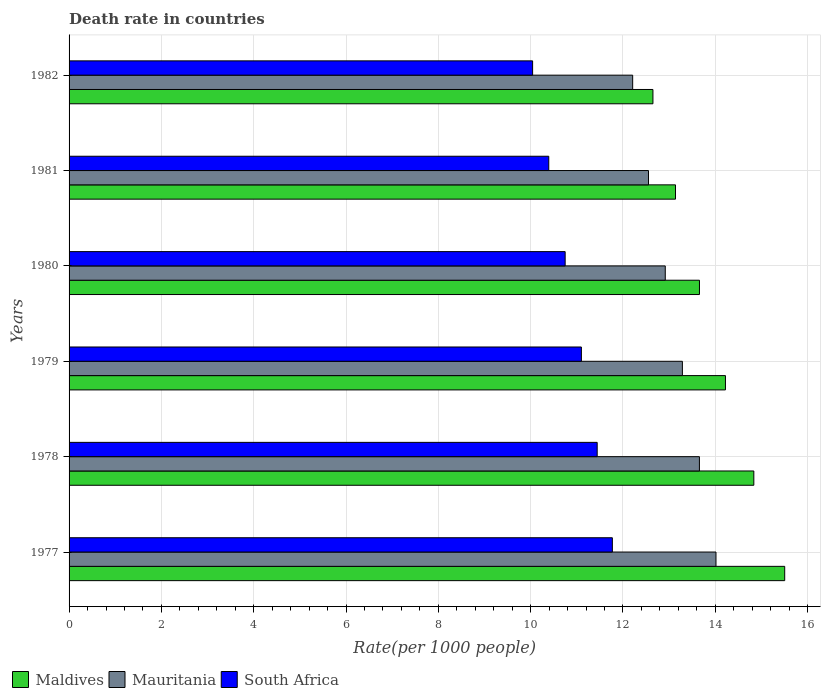How many different coloured bars are there?
Keep it short and to the point. 3. How many groups of bars are there?
Provide a succinct answer. 6. Are the number of bars on each tick of the Y-axis equal?
Your answer should be very brief. Yes. How many bars are there on the 3rd tick from the top?
Offer a very short reply. 3. What is the label of the 4th group of bars from the top?
Offer a very short reply. 1979. In how many cases, is the number of bars for a given year not equal to the number of legend labels?
Your answer should be compact. 0. What is the death rate in Mauritania in 1977?
Provide a succinct answer. 14.02. Across all years, what is the maximum death rate in South Africa?
Offer a very short reply. 11.77. Across all years, what is the minimum death rate in Mauritania?
Your response must be concise. 12.21. What is the total death rate in Maldives in the graph?
Your answer should be very brief. 84.01. What is the difference between the death rate in South Africa in 1978 and that in 1982?
Ensure brevity in your answer.  1.4. What is the difference between the death rate in South Africa in 1981 and the death rate in Maldives in 1982?
Offer a very short reply. -2.26. What is the average death rate in South Africa per year?
Provide a succinct answer. 10.92. In the year 1982, what is the difference between the death rate in South Africa and death rate in Mauritania?
Your response must be concise. -2.17. In how many years, is the death rate in Mauritania greater than 9.2 ?
Your response must be concise. 6. What is the ratio of the death rate in Mauritania in 1978 to that in 1981?
Your answer should be very brief. 1.09. Is the difference between the death rate in South Africa in 1978 and 1980 greater than the difference between the death rate in Mauritania in 1978 and 1980?
Your response must be concise. No. What is the difference between the highest and the second highest death rate in Mauritania?
Your answer should be compact. 0.36. What is the difference between the highest and the lowest death rate in Maldives?
Provide a succinct answer. 2.86. In how many years, is the death rate in Maldives greater than the average death rate in Maldives taken over all years?
Provide a short and direct response. 3. What does the 1st bar from the top in 1979 represents?
Keep it short and to the point. South Africa. What does the 2nd bar from the bottom in 1980 represents?
Give a very brief answer. Mauritania. How many bars are there?
Ensure brevity in your answer.  18. Are all the bars in the graph horizontal?
Your response must be concise. Yes. How many years are there in the graph?
Provide a short and direct response. 6. Are the values on the major ticks of X-axis written in scientific E-notation?
Your answer should be compact. No. Does the graph contain any zero values?
Offer a very short reply. No. Where does the legend appear in the graph?
Make the answer very short. Bottom left. How many legend labels are there?
Provide a short and direct response. 3. What is the title of the graph?
Your answer should be very brief. Death rate in countries. What is the label or title of the X-axis?
Provide a short and direct response. Rate(per 1000 people). What is the Rate(per 1000 people) of Maldives in 1977?
Provide a succinct answer. 15.51. What is the Rate(per 1000 people) of Mauritania in 1977?
Keep it short and to the point. 14.02. What is the Rate(per 1000 people) in South Africa in 1977?
Provide a succinct answer. 11.77. What is the Rate(per 1000 people) of Maldives in 1978?
Your response must be concise. 14.84. What is the Rate(per 1000 people) of Mauritania in 1978?
Offer a very short reply. 13.66. What is the Rate(per 1000 people) of South Africa in 1978?
Ensure brevity in your answer.  11.44. What is the Rate(per 1000 people) of Maldives in 1979?
Your answer should be compact. 14.22. What is the Rate(per 1000 people) in Mauritania in 1979?
Give a very brief answer. 13.29. What is the Rate(per 1000 people) of South Africa in 1979?
Provide a succinct answer. 11.1. What is the Rate(per 1000 people) of Maldives in 1980?
Your response must be concise. 13.66. What is the Rate(per 1000 people) in Mauritania in 1980?
Your response must be concise. 12.92. What is the Rate(per 1000 people) in South Africa in 1980?
Your response must be concise. 10.75. What is the Rate(per 1000 people) of Maldives in 1981?
Your answer should be very brief. 13.14. What is the Rate(per 1000 people) in Mauritania in 1981?
Make the answer very short. 12.55. What is the Rate(per 1000 people) in South Africa in 1981?
Offer a very short reply. 10.39. What is the Rate(per 1000 people) of Maldives in 1982?
Provide a short and direct response. 12.65. What is the Rate(per 1000 people) in Mauritania in 1982?
Your response must be concise. 12.21. What is the Rate(per 1000 people) in South Africa in 1982?
Keep it short and to the point. 10.04. Across all years, what is the maximum Rate(per 1000 people) in Maldives?
Offer a very short reply. 15.51. Across all years, what is the maximum Rate(per 1000 people) in Mauritania?
Your response must be concise. 14.02. Across all years, what is the maximum Rate(per 1000 people) in South Africa?
Offer a terse response. 11.77. Across all years, what is the minimum Rate(per 1000 people) of Maldives?
Your response must be concise. 12.65. Across all years, what is the minimum Rate(per 1000 people) in Mauritania?
Give a very brief answer. 12.21. Across all years, what is the minimum Rate(per 1000 people) of South Africa?
Make the answer very short. 10.04. What is the total Rate(per 1000 people) in Maldives in the graph?
Provide a succinct answer. 84.01. What is the total Rate(per 1000 people) in Mauritania in the graph?
Keep it short and to the point. 78.64. What is the total Rate(per 1000 people) in South Africa in the graph?
Your answer should be compact. 65.5. What is the difference between the Rate(per 1000 people) in Maldives in 1977 and that in 1978?
Offer a very short reply. 0.67. What is the difference between the Rate(per 1000 people) in Mauritania in 1977 and that in 1978?
Make the answer very short. 0.36. What is the difference between the Rate(per 1000 people) in South Africa in 1977 and that in 1978?
Offer a very short reply. 0.33. What is the difference between the Rate(per 1000 people) in Maldives in 1977 and that in 1979?
Ensure brevity in your answer.  1.28. What is the difference between the Rate(per 1000 people) of Mauritania in 1977 and that in 1979?
Provide a succinct answer. 0.73. What is the difference between the Rate(per 1000 people) in South Africa in 1977 and that in 1979?
Your answer should be compact. 0.67. What is the difference between the Rate(per 1000 people) in Maldives in 1977 and that in 1980?
Provide a short and direct response. 1.85. What is the difference between the Rate(per 1000 people) in Mauritania in 1977 and that in 1980?
Make the answer very short. 1.1. What is the difference between the Rate(per 1000 people) in Maldives in 1977 and that in 1981?
Offer a terse response. 2.37. What is the difference between the Rate(per 1000 people) of Mauritania in 1977 and that in 1981?
Offer a terse response. 1.46. What is the difference between the Rate(per 1000 people) of South Africa in 1977 and that in 1981?
Your answer should be very brief. 1.38. What is the difference between the Rate(per 1000 people) in Maldives in 1977 and that in 1982?
Offer a very short reply. 2.85. What is the difference between the Rate(per 1000 people) of Mauritania in 1977 and that in 1982?
Your response must be concise. 1.8. What is the difference between the Rate(per 1000 people) of South Africa in 1977 and that in 1982?
Give a very brief answer. 1.73. What is the difference between the Rate(per 1000 people) in Maldives in 1978 and that in 1979?
Your response must be concise. 0.61. What is the difference between the Rate(per 1000 people) in Mauritania in 1978 and that in 1979?
Give a very brief answer. 0.37. What is the difference between the Rate(per 1000 people) of South Africa in 1978 and that in 1979?
Make the answer very short. 0.34. What is the difference between the Rate(per 1000 people) in Maldives in 1978 and that in 1980?
Give a very brief answer. 1.18. What is the difference between the Rate(per 1000 people) in Mauritania in 1978 and that in 1980?
Ensure brevity in your answer.  0.74. What is the difference between the Rate(per 1000 people) in South Africa in 1978 and that in 1980?
Ensure brevity in your answer.  0.69. What is the difference between the Rate(per 1000 people) of Maldives in 1978 and that in 1981?
Your response must be concise. 1.7. What is the difference between the Rate(per 1000 people) in Mauritania in 1978 and that in 1981?
Offer a terse response. 1.1. What is the difference between the Rate(per 1000 people) in South Africa in 1978 and that in 1981?
Provide a short and direct response. 1.05. What is the difference between the Rate(per 1000 people) in Maldives in 1978 and that in 1982?
Offer a terse response. 2.19. What is the difference between the Rate(per 1000 people) of Mauritania in 1978 and that in 1982?
Provide a succinct answer. 1.45. What is the difference between the Rate(per 1000 people) in South Africa in 1978 and that in 1982?
Give a very brief answer. 1.4. What is the difference between the Rate(per 1000 people) in Maldives in 1979 and that in 1980?
Offer a very short reply. 0.56. What is the difference between the Rate(per 1000 people) in Mauritania in 1979 and that in 1980?
Make the answer very short. 0.37. What is the difference between the Rate(per 1000 people) in South Africa in 1979 and that in 1980?
Your answer should be compact. 0.35. What is the difference between the Rate(per 1000 people) of Maldives in 1979 and that in 1981?
Provide a succinct answer. 1.08. What is the difference between the Rate(per 1000 people) of Mauritania in 1979 and that in 1981?
Keep it short and to the point. 0.73. What is the difference between the Rate(per 1000 people) in South Africa in 1979 and that in 1981?
Offer a terse response. 0.71. What is the difference between the Rate(per 1000 people) of Maldives in 1979 and that in 1982?
Provide a succinct answer. 1.57. What is the difference between the Rate(per 1000 people) in Mauritania in 1979 and that in 1982?
Ensure brevity in your answer.  1.08. What is the difference between the Rate(per 1000 people) in South Africa in 1979 and that in 1982?
Provide a short and direct response. 1.06. What is the difference between the Rate(per 1000 people) in Maldives in 1980 and that in 1981?
Provide a succinct answer. 0.52. What is the difference between the Rate(per 1000 people) in Mauritania in 1980 and that in 1981?
Offer a terse response. 0.36. What is the difference between the Rate(per 1000 people) of South Africa in 1980 and that in 1981?
Provide a short and direct response. 0.35. What is the difference between the Rate(per 1000 people) of Maldives in 1980 and that in 1982?
Provide a short and direct response. 1.01. What is the difference between the Rate(per 1000 people) of Mauritania in 1980 and that in 1982?
Your answer should be very brief. 0.71. What is the difference between the Rate(per 1000 people) in South Africa in 1980 and that in 1982?
Your answer should be very brief. 0.7. What is the difference between the Rate(per 1000 people) in Maldives in 1981 and that in 1982?
Keep it short and to the point. 0.49. What is the difference between the Rate(per 1000 people) in Mauritania in 1981 and that in 1982?
Provide a short and direct response. 0.34. What is the difference between the Rate(per 1000 people) of South Africa in 1981 and that in 1982?
Keep it short and to the point. 0.35. What is the difference between the Rate(per 1000 people) of Maldives in 1977 and the Rate(per 1000 people) of Mauritania in 1978?
Make the answer very short. 1.85. What is the difference between the Rate(per 1000 people) in Maldives in 1977 and the Rate(per 1000 people) in South Africa in 1978?
Make the answer very short. 4.06. What is the difference between the Rate(per 1000 people) of Mauritania in 1977 and the Rate(per 1000 people) of South Africa in 1978?
Your answer should be compact. 2.57. What is the difference between the Rate(per 1000 people) in Maldives in 1977 and the Rate(per 1000 people) in Mauritania in 1979?
Give a very brief answer. 2.22. What is the difference between the Rate(per 1000 people) in Maldives in 1977 and the Rate(per 1000 people) in South Africa in 1979?
Make the answer very short. 4.41. What is the difference between the Rate(per 1000 people) of Mauritania in 1977 and the Rate(per 1000 people) of South Africa in 1979?
Provide a short and direct response. 2.92. What is the difference between the Rate(per 1000 people) in Maldives in 1977 and the Rate(per 1000 people) in Mauritania in 1980?
Ensure brevity in your answer.  2.59. What is the difference between the Rate(per 1000 people) of Maldives in 1977 and the Rate(per 1000 people) of South Africa in 1980?
Make the answer very short. 4.76. What is the difference between the Rate(per 1000 people) of Mauritania in 1977 and the Rate(per 1000 people) of South Africa in 1980?
Offer a terse response. 3.27. What is the difference between the Rate(per 1000 people) of Maldives in 1977 and the Rate(per 1000 people) of Mauritania in 1981?
Your response must be concise. 2.95. What is the difference between the Rate(per 1000 people) of Maldives in 1977 and the Rate(per 1000 people) of South Africa in 1981?
Give a very brief answer. 5.11. What is the difference between the Rate(per 1000 people) in Mauritania in 1977 and the Rate(per 1000 people) in South Africa in 1981?
Provide a short and direct response. 3.62. What is the difference between the Rate(per 1000 people) in Maldives in 1977 and the Rate(per 1000 people) in Mauritania in 1982?
Provide a short and direct response. 3.29. What is the difference between the Rate(per 1000 people) of Maldives in 1977 and the Rate(per 1000 people) of South Africa in 1982?
Provide a short and direct response. 5.46. What is the difference between the Rate(per 1000 people) of Mauritania in 1977 and the Rate(per 1000 people) of South Africa in 1982?
Offer a very short reply. 3.97. What is the difference between the Rate(per 1000 people) in Maldives in 1978 and the Rate(per 1000 people) in Mauritania in 1979?
Provide a short and direct response. 1.55. What is the difference between the Rate(per 1000 people) in Maldives in 1978 and the Rate(per 1000 people) in South Africa in 1979?
Your response must be concise. 3.74. What is the difference between the Rate(per 1000 people) of Mauritania in 1978 and the Rate(per 1000 people) of South Africa in 1979?
Provide a short and direct response. 2.56. What is the difference between the Rate(per 1000 people) of Maldives in 1978 and the Rate(per 1000 people) of Mauritania in 1980?
Offer a terse response. 1.92. What is the difference between the Rate(per 1000 people) of Maldives in 1978 and the Rate(per 1000 people) of South Africa in 1980?
Make the answer very short. 4.09. What is the difference between the Rate(per 1000 people) in Mauritania in 1978 and the Rate(per 1000 people) in South Africa in 1980?
Keep it short and to the point. 2.91. What is the difference between the Rate(per 1000 people) of Maldives in 1978 and the Rate(per 1000 people) of Mauritania in 1981?
Make the answer very short. 2.28. What is the difference between the Rate(per 1000 people) in Maldives in 1978 and the Rate(per 1000 people) in South Africa in 1981?
Ensure brevity in your answer.  4.44. What is the difference between the Rate(per 1000 people) in Mauritania in 1978 and the Rate(per 1000 people) in South Africa in 1981?
Your response must be concise. 3.26. What is the difference between the Rate(per 1000 people) in Maldives in 1978 and the Rate(per 1000 people) in Mauritania in 1982?
Give a very brief answer. 2.62. What is the difference between the Rate(per 1000 people) in Maldives in 1978 and the Rate(per 1000 people) in South Africa in 1982?
Your answer should be very brief. 4.79. What is the difference between the Rate(per 1000 people) in Mauritania in 1978 and the Rate(per 1000 people) in South Africa in 1982?
Your response must be concise. 3.61. What is the difference between the Rate(per 1000 people) of Maldives in 1979 and the Rate(per 1000 people) of Mauritania in 1980?
Give a very brief answer. 1.3. What is the difference between the Rate(per 1000 people) of Maldives in 1979 and the Rate(per 1000 people) of South Africa in 1980?
Keep it short and to the point. 3.47. What is the difference between the Rate(per 1000 people) of Mauritania in 1979 and the Rate(per 1000 people) of South Africa in 1980?
Your response must be concise. 2.54. What is the difference between the Rate(per 1000 people) of Maldives in 1979 and the Rate(per 1000 people) of Mauritania in 1981?
Give a very brief answer. 1.67. What is the difference between the Rate(per 1000 people) of Maldives in 1979 and the Rate(per 1000 people) of South Africa in 1981?
Make the answer very short. 3.83. What is the difference between the Rate(per 1000 people) in Mauritania in 1979 and the Rate(per 1000 people) in South Africa in 1981?
Make the answer very short. 2.9. What is the difference between the Rate(per 1000 people) in Maldives in 1979 and the Rate(per 1000 people) in Mauritania in 1982?
Keep it short and to the point. 2.01. What is the difference between the Rate(per 1000 people) in Maldives in 1979 and the Rate(per 1000 people) in South Africa in 1982?
Provide a short and direct response. 4.18. What is the difference between the Rate(per 1000 people) in Mauritania in 1979 and the Rate(per 1000 people) in South Africa in 1982?
Make the answer very short. 3.25. What is the difference between the Rate(per 1000 people) in Maldives in 1980 and the Rate(per 1000 people) in Mauritania in 1981?
Make the answer very short. 1.1. What is the difference between the Rate(per 1000 people) in Maldives in 1980 and the Rate(per 1000 people) in South Africa in 1981?
Give a very brief answer. 3.27. What is the difference between the Rate(per 1000 people) in Mauritania in 1980 and the Rate(per 1000 people) in South Africa in 1981?
Give a very brief answer. 2.52. What is the difference between the Rate(per 1000 people) in Maldives in 1980 and the Rate(per 1000 people) in Mauritania in 1982?
Make the answer very short. 1.45. What is the difference between the Rate(per 1000 people) in Maldives in 1980 and the Rate(per 1000 people) in South Africa in 1982?
Offer a terse response. 3.62. What is the difference between the Rate(per 1000 people) of Mauritania in 1980 and the Rate(per 1000 people) of South Africa in 1982?
Your answer should be compact. 2.87. What is the difference between the Rate(per 1000 people) in Maldives in 1981 and the Rate(per 1000 people) in Mauritania in 1982?
Your response must be concise. 0.93. What is the difference between the Rate(per 1000 people) of Maldives in 1981 and the Rate(per 1000 people) of South Africa in 1982?
Provide a succinct answer. 3.1. What is the difference between the Rate(per 1000 people) in Mauritania in 1981 and the Rate(per 1000 people) in South Africa in 1982?
Make the answer very short. 2.51. What is the average Rate(per 1000 people) of Maldives per year?
Offer a terse response. 14. What is the average Rate(per 1000 people) in Mauritania per year?
Your answer should be compact. 13.11. What is the average Rate(per 1000 people) in South Africa per year?
Offer a very short reply. 10.92. In the year 1977, what is the difference between the Rate(per 1000 people) in Maldives and Rate(per 1000 people) in Mauritania?
Your response must be concise. 1.49. In the year 1977, what is the difference between the Rate(per 1000 people) of Maldives and Rate(per 1000 people) of South Africa?
Provide a succinct answer. 3.73. In the year 1977, what is the difference between the Rate(per 1000 people) in Mauritania and Rate(per 1000 people) in South Africa?
Ensure brevity in your answer.  2.25. In the year 1978, what is the difference between the Rate(per 1000 people) of Maldives and Rate(per 1000 people) of Mauritania?
Your answer should be compact. 1.18. In the year 1978, what is the difference between the Rate(per 1000 people) of Maldives and Rate(per 1000 people) of South Africa?
Your answer should be very brief. 3.39. In the year 1978, what is the difference between the Rate(per 1000 people) of Mauritania and Rate(per 1000 people) of South Africa?
Ensure brevity in your answer.  2.21. In the year 1979, what is the difference between the Rate(per 1000 people) of Maldives and Rate(per 1000 people) of Mauritania?
Provide a succinct answer. 0.93. In the year 1979, what is the difference between the Rate(per 1000 people) in Maldives and Rate(per 1000 people) in South Africa?
Your response must be concise. 3.12. In the year 1979, what is the difference between the Rate(per 1000 people) in Mauritania and Rate(per 1000 people) in South Africa?
Make the answer very short. 2.19. In the year 1980, what is the difference between the Rate(per 1000 people) in Maldives and Rate(per 1000 people) in Mauritania?
Your answer should be compact. 0.74. In the year 1980, what is the difference between the Rate(per 1000 people) in Maldives and Rate(per 1000 people) in South Africa?
Provide a short and direct response. 2.91. In the year 1980, what is the difference between the Rate(per 1000 people) of Mauritania and Rate(per 1000 people) of South Africa?
Provide a succinct answer. 2.17. In the year 1981, what is the difference between the Rate(per 1000 people) of Maldives and Rate(per 1000 people) of Mauritania?
Offer a terse response. 0.58. In the year 1981, what is the difference between the Rate(per 1000 people) in Maldives and Rate(per 1000 people) in South Africa?
Your answer should be compact. 2.75. In the year 1981, what is the difference between the Rate(per 1000 people) in Mauritania and Rate(per 1000 people) in South Africa?
Provide a short and direct response. 2.16. In the year 1982, what is the difference between the Rate(per 1000 people) in Maldives and Rate(per 1000 people) in Mauritania?
Provide a succinct answer. 0.44. In the year 1982, what is the difference between the Rate(per 1000 people) of Maldives and Rate(per 1000 people) of South Africa?
Your answer should be compact. 2.61. In the year 1982, what is the difference between the Rate(per 1000 people) in Mauritania and Rate(per 1000 people) in South Africa?
Your answer should be very brief. 2.17. What is the ratio of the Rate(per 1000 people) of Maldives in 1977 to that in 1978?
Your answer should be very brief. 1.05. What is the ratio of the Rate(per 1000 people) in Mauritania in 1977 to that in 1978?
Provide a succinct answer. 1.03. What is the ratio of the Rate(per 1000 people) of South Africa in 1977 to that in 1978?
Provide a succinct answer. 1.03. What is the ratio of the Rate(per 1000 people) in Maldives in 1977 to that in 1979?
Offer a terse response. 1.09. What is the ratio of the Rate(per 1000 people) of Mauritania in 1977 to that in 1979?
Your response must be concise. 1.05. What is the ratio of the Rate(per 1000 people) of South Africa in 1977 to that in 1979?
Your answer should be compact. 1.06. What is the ratio of the Rate(per 1000 people) in Maldives in 1977 to that in 1980?
Provide a succinct answer. 1.14. What is the ratio of the Rate(per 1000 people) in Mauritania in 1977 to that in 1980?
Make the answer very short. 1.09. What is the ratio of the Rate(per 1000 people) in South Africa in 1977 to that in 1980?
Offer a terse response. 1.1. What is the ratio of the Rate(per 1000 people) of Maldives in 1977 to that in 1981?
Your response must be concise. 1.18. What is the ratio of the Rate(per 1000 people) in Mauritania in 1977 to that in 1981?
Your answer should be very brief. 1.12. What is the ratio of the Rate(per 1000 people) of South Africa in 1977 to that in 1981?
Keep it short and to the point. 1.13. What is the ratio of the Rate(per 1000 people) in Maldives in 1977 to that in 1982?
Your response must be concise. 1.23. What is the ratio of the Rate(per 1000 people) in Mauritania in 1977 to that in 1982?
Offer a terse response. 1.15. What is the ratio of the Rate(per 1000 people) in South Africa in 1977 to that in 1982?
Keep it short and to the point. 1.17. What is the ratio of the Rate(per 1000 people) in Maldives in 1978 to that in 1979?
Ensure brevity in your answer.  1.04. What is the ratio of the Rate(per 1000 people) of Mauritania in 1978 to that in 1979?
Give a very brief answer. 1.03. What is the ratio of the Rate(per 1000 people) in South Africa in 1978 to that in 1979?
Make the answer very short. 1.03. What is the ratio of the Rate(per 1000 people) in Maldives in 1978 to that in 1980?
Make the answer very short. 1.09. What is the ratio of the Rate(per 1000 people) of Mauritania in 1978 to that in 1980?
Provide a short and direct response. 1.06. What is the ratio of the Rate(per 1000 people) in South Africa in 1978 to that in 1980?
Your answer should be compact. 1.06. What is the ratio of the Rate(per 1000 people) in Maldives in 1978 to that in 1981?
Offer a terse response. 1.13. What is the ratio of the Rate(per 1000 people) in Mauritania in 1978 to that in 1981?
Your response must be concise. 1.09. What is the ratio of the Rate(per 1000 people) of South Africa in 1978 to that in 1981?
Ensure brevity in your answer.  1.1. What is the ratio of the Rate(per 1000 people) in Maldives in 1978 to that in 1982?
Provide a short and direct response. 1.17. What is the ratio of the Rate(per 1000 people) of Mauritania in 1978 to that in 1982?
Give a very brief answer. 1.12. What is the ratio of the Rate(per 1000 people) in South Africa in 1978 to that in 1982?
Your answer should be compact. 1.14. What is the ratio of the Rate(per 1000 people) in Maldives in 1979 to that in 1980?
Offer a very short reply. 1.04. What is the ratio of the Rate(per 1000 people) in Mauritania in 1979 to that in 1980?
Keep it short and to the point. 1.03. What is the ratio of the Rate(per 1000 people) of South Africa in 1979 to that in 1980?
Provide a succinct answer. 1.03. What is the ratio of the Rate(per 1000 people) in Maldives in 1979 to that in 1981?
Your answer should be compact. 1.08. What is the ratio of the Rate(per 1000 people) in Mauritania in 1979 to that in 1981?
Keep it short and to the point. 1.06. What is the ratio of the Rate(per 1000 people) of South Africa in 1979 to that in 1981?
Your answer should be very brief. 1.07. What is the ratio of the Rate(per 1000 people) in Maldives in 1979 to that in 1982?
Ensure brevity in your answer.  1.12. What is the ratio of the Rate(per 1000 people) in Mauritania in 1979 to that in 1982?
Make the answer very short. 1.09. What is the ratio of the Rate(per 1000 people) in South Africa in 1979 to that in 1982?
Offer a terse response. 1.11. What is the ratio of the Rate(per 1000 people) of Maldives in 1980 to that in 1981?
Ensure brevity in your answer.  1.04. What is the ratio of the Rate(per 1000 people) of Mauritania in 1980 to that in 1981?
Offer a very short reply. 1.03. What is the ratio of the Rate(per 1000 people) in South Africa in 1980 to that in 1981?
Your response must be concise. 1.03. What is the ratio of the Rate(per 1000 people) in Maldives in 1980 to that in 1982?
Keep it short and to the point. 1.08. What is the ratio of the Rate(per 1000 people) of Mauritania in 1980 to that in 1982?
Your answer should be very brief. 1.06. What is the ratio of the Rate(per 1000 people) in South Africa in 1980 to that in 1982?
Your answer should be very brief. 1.07. What is the ratio of the Rate(per 1000 people) of Maldives in 1981 to that in 1982?
Make the answer very short. 1.04. What is the ratio of the Rate(per 1000 people) in Mauritania in 1981 to that in 1982?
Your response must be concise. 1.03. What is the ratio of the Rate(per 1000 people) of South Africa in 1981 to that in 1982?
Your answer should be compact. 1.03. What is the difference between the highest and the second highest Rate(per 1000 people) of Maldives?
Your response must be concise. 0.67. What is the difference between the highest and the second highest Rate(per 1000 people) in Mauritania?
Make the answer very short. 0.36. What is the difference between the highest and the second highest Rate(per 1000 people) in South Africa?
Ensure brevity in your answer.  0.33. What is the difference between the highest and the lowest Rate(per 1000 people) of Maldives?
Your answer should be compact. 2.85. What is the difference between the highest and the lowest Rate(per 1000 people) in Mauritania?
Give a very brief answer. 1.8. What is the difference between the highest and the lowest Rate(per 1000 people) of South Africa?
Your answer should be very brief. 1.73. 